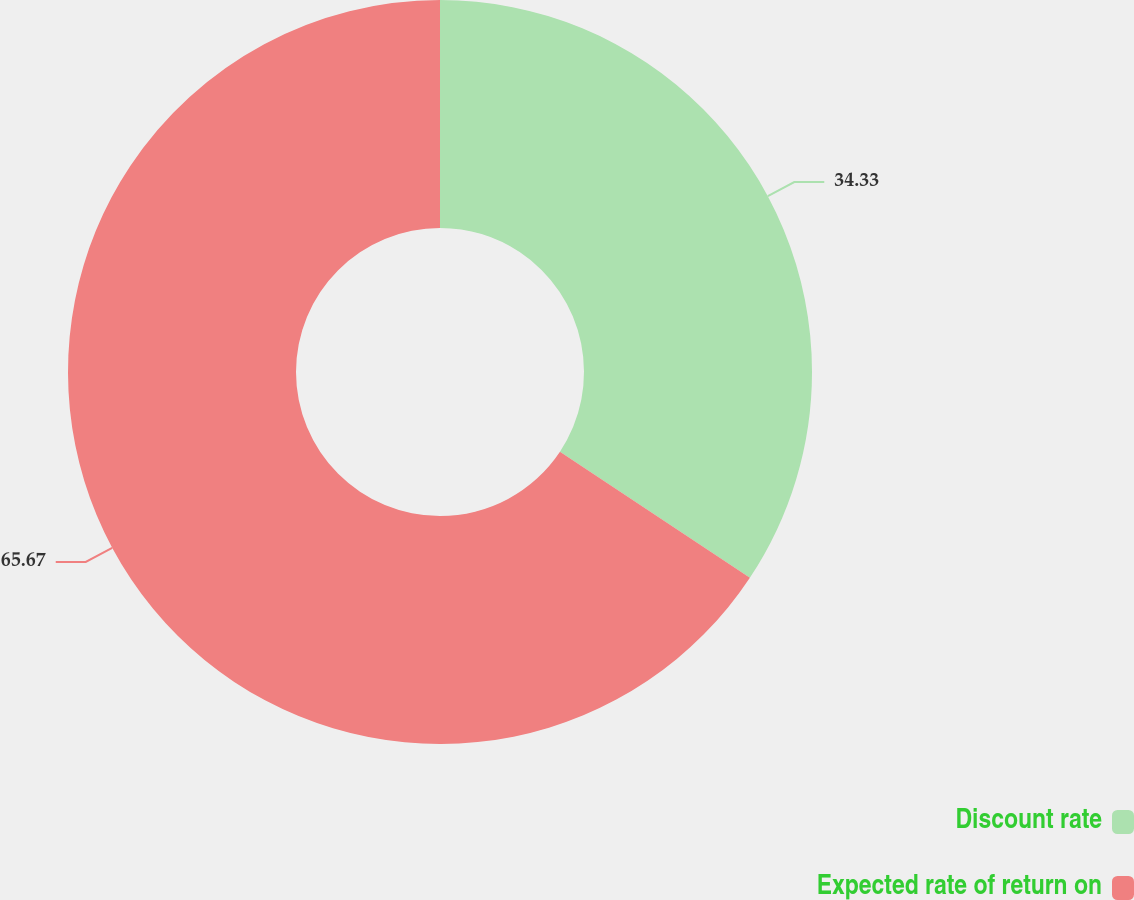Convert chart to OTSL. <chart><loc_0><loc_0><loc_500><loc_500><pie_chart><fcel>Discount rate<fcel>Expected rate of return on<nl><fcel>34.33%<fcel>65.67%<nl></chart> 